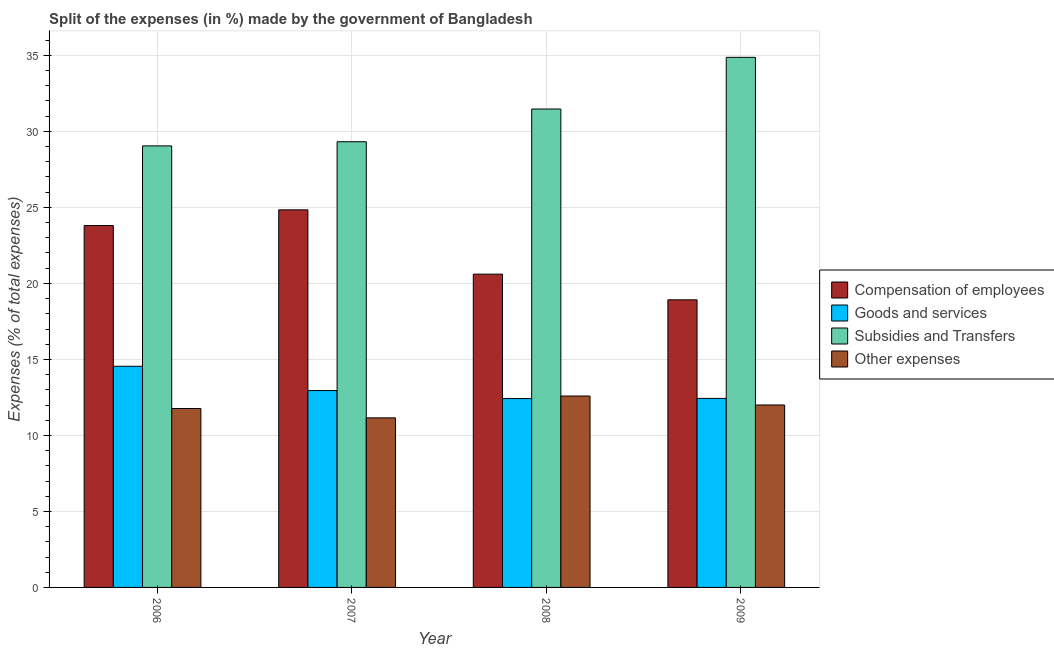How many different coloured bars are there?
Your answer should be compact. 4. How many groups of bars are there?
Give a very brief answer. 4. Are the number of bars on each tick of the X-axis equal?
Provide a succinct answer. Yes. How many bars are there on the 2nd tick from the right?
Offer a very short reply. 4. In how many cases, is the number of bars for a given year not equal to the number of legend labels?
Offer a very short reply. 0. What is the percentage of amount spent on other expenses in 2008?
Your answer should be compact. 12.59. Across all years, what is the maximum percentage of amount spent on compensation of employees?
Keep it short and to the point. 24.84. Across all years, what is the minimum percentage of amount spent on compensation of employees?
Your answer should be compact. 18.92. In which year was the percentage of amount spent on goods and services maximum?
Ensure brevity in your answer.  2006. What is the total percentage of amount spent on subsidies in the graph?
Offer a very short reply. 124.71. What is the difference between the percentage of amount spent on goods and services in 2007 and that in 2009?
Give a very brief answer. 0.52. What is the difference between the percentage of amount spent on subsidies in 2008 and the percentage of amount spent on goods and services in 2006?
Ensure brevity in your answer.  2.43. What is the average percentage of amount spent on compensation of employees per year?
Give a very brief answer. 22.04. In the year 2007, what is the difference between the percentage of amount spent on compensation of employees and percentage of amount spent on other expenses?
Ensure brevity in your answer.  0. In how many years, is the percentage of amount spent on other expenses greater than 31 %?
Give a very brief answer. 0. What is the ratio of the percentage of amount spent on compensation of employees in 2006 to that in 2007?
Give a very brief answer. 0.96. What is the difference between the highest and the second highest percentage of amount spent on subsidies?
Make the answer very short. 3.4. What is the difference between the highest and the lowest percentage of amount spent on compensation of employees?
Provide a succinct answer. 5.92. In how many years, is the percentage of amount spent on goods and services greater than the average percentage of amount spent on goods and services taken over all years?
Offer a very short reply. 1. Is the sum of the percentage of amount spent on goods and services in 2006 and 2007 greater than the maximum percentage of amount spent on compensation of employees across all years?
Provide a succinct answer. Yes. What does the 3rd bar from the left in 2006 represents?
Provide a short and direct response. Subsidies and Transfers. What does the 1st bar from the right in 2007 represents?
Offer a terse response. Other expenses. Is it the case that in every year, the sum of the percentage of amount spent on compensation of employees and percentage of amount spent on goods and services is greater than the percentage of amount spent on subsidies?
Offer a very short reply. No. Are all the bars in the graph horizontal?
Offer a very short reply. No. How many years are there in the graph?
Offer a very short reply. 4. How are the legend labels stacked?
Your response must be concise. Vertical. What is the title of the graph?
Your answer should be very brief. Split of the expenses (in %) made by the government of Bangladesh. What is the label or title of the X-axis?
Your answer should be compact. Year. What is the label or title of the Y-axis?
Offer a terse response. Expenses (% of total expenses). What is the Expenses (% of total expenses) of Compensation of employees in 2006?
Make the answer very short. 23.81. What is the Expenses (% of total expenses) of Goods and services in 2006?
Ensure brevity in your answer.  14.55. What is the Expenses (% of total expenses) in Subsidies and Transfers in 2006?
Make the answer very short. 29.05. What is the Expenses (% of total expenses) of Other expenses in 2006?
Offer a terse response. 11.77. What is the Expenses (% of total expenses) of Compensation of employees in 2007?
Your response must be concise. 24.84. What is the Expenses (% of total expenses) in Goods and services in 2007?
Make the answer very short. 12.95. What is the Expenses (% of total expenses) in Subsidies and Transfers in 2007?
Offer a very short reply. 29.32. What is the Expenses (% of total expenses) in Other expenses in 2007?
Your answer should be very brief. 11.16. What is the Expenses (% of total expenses) of Compensation of employees in 2008?
Make the answer very short. 20.61. What is the Expenses (% of total expenses) in Goods and services in 2008?
Provide a succinct answer. 12.42. What is the Expenses (% of total expenses) of Subsidies and Transfers in 2008?
Offer a very short reply. 31.47. What is the Expenses (% of total expenses) of Other expenses in 2008?
Give a very brief answer. 12.59. What is the Expenses (% of total expenses) in Compensation of employees in 2009?
Your answer should be very brief. 18.92. What is the Expenses (% of total expenses) of Goods and services in 2009?
Offer a very short reply. 12.44. What is the Expenses (% of total expenses) of Subsidies and Transfers in 2009?
Provide a short and direct response. 34.87. What is the Expenses (% of total expenses) in Other expenses in 2009?
Offer a very short reply. 12. Across all years, what is the maximum Expenses (% of total expenses) of Compensation of employees?
Your response must be concise. 24.84. Across all years, what is the maximum Expenses (% of total expenses) in Goods and services?
Keep it short and to the point. 14.55. Across all years, what is the maximum Expenses (% of total expenses) of Subsidies and Transfers?
Ensure brevity in your answer.  34.87. Across all years, what is the maximum Expenses (% of total expenses) of Other expenses?
Provide a short and direct response. 12.59. Across all years, what is the minimum Expenses (% of total expenses) of Compensation of employees?
Ensure brevity in your answer.  18.92. Across all years, what is the minimum Expenses (% of total expenses) of Goods and services?
Offer a terse response. 12.42. Across all years, what is the minimum Expenses (% of total expenses) of Subsidies and Transfers?
Your answer should be compact. 29.05. Across all years, what is the minimum Expenses (% of total expenses) of Other expenses?
Offer a terse response. 11.16. What is the total Expenses (% of total expenses) in Compensation of employees in the graph?
Provide a succinct answer. 88.17. What is the total Expenses (% of total expenses) of Goods and services in the graph?
Your answer should be very brief. 52.36. What is the total Expenses (% of total expenses) of Subsidies and Transfers in the graph?
Keep it short and to the point. 124.71. What is the total Expenses (% of total expenses) of Other expenses in the graph?
Ensure brevity in your answer.  47.52. What is the difference between the Expenses (% of total expenses) of Compensation of employees in 2006 and that in 2007?
Ensure brevity in your answer.  -1.03. What is the difference between the Expenses (% of total expenses) of Goods and services in 2006 and that in 2007?
Keep it short and to the point. 1.6. What is the difference between the Expenses (% of total expenses) of Subsidies and Transfers in 2006 and that in 2007?
Provide a succinct answer. -0.27. What is the difference between the Expenses (% of total expenses) of Other expenses in 2006 and that in 2007?
Offer a very short reply. 0.62. What is the difference between the Expenses (% of total expenses) of Compensation of employees in 2006 and that in 2008?
Ensure brevity in your answer.  3.2. What is the difference between the Expenses (% of total expenses) of Goods and services in 2006 and that in 2008?
Ensure brevity in your answer.  2.12. What is the difference between the Expenses (% of total expenses) of Subsidies and Transfers in 2006 and that in 2008?
Offer a very short reply. -2.43. What is the difference between the Expenses (% of total expenses) of Other expenses in 2006 and that in 2008?
Keep it short and to the point. -0.82. What is the difference between the Expenses (% of total expenses) in Compensation of employees in 2006 and that in 2009?
Your answer should be compact. 4.89. What is the difference between the Expenses (% of total expenses) of Goods and services in 2006 and that in 2009?
Provide a succinct answer. 2.11. What is the difference between the Expenses (% of total expenses) in Subsidies and Transfers in 2006 and that in 2009?
Your response must be concise. -5.83. What is the difference between the Expenses (% of total expenses) in Other expenses in 2006 and that in 2009?
Provide a succinct answer. -0.23. What is the difference between the Expenses (% of total expenses) of Compensation of employees in 2007 and that in 2008?
Ensure brevity in your answer.  4.23. What is the difference between the Expenses (% of total expenses) in Goods and services in 2007 and that in 2008?
Keep it short and to the point. 0.53. What is the difference between the Expenses (% of total expenses) in Subsidies and Transfers in 2007 and that in 2008?
Provide a succinct answer. -2.15. What is the difference between the Expenses (% of total expenses) of Other expenses in 2007 and that in 2008?
Make the answer very short. -1.44. What is the difference between the Expenses (% of total expenses) in Compensation of employees in 2007 and that in 2009?
Ensure brevity in your answer.  5.92. What is the difference between the Expenses (% of total expenses) in Goods and services in 2007 and that in 2009?
Offer a very short reply. 0.52. What is the difference between the Expenses (% of total expenses) in Subsidies and Transfers in 2007 and that in 2009?
Provide a succinct answer. -5.55. What is the difference between the Expenses (% of total expenses) in Other expenses in 2007 and that in 2009?
Keep it short and to the point. -0.85. What is the difference between the Expenses (% of total expenses) in Compensation of employees in 2008 and that in 2009?
Make the answer very short. 1.69. What is the difference between the Expenses (% of total expenses) in Goods and services in 2008 and that in 2009?
Your answer should be compact. -0.01. What is the difference between the Expenses (% of total expenses) in Subsidies and Transfers in 2008 and that in 2009?
Your answer should be compact. -3.4. What is the difference between the Expenses (% of total expenses) in Other expenses in 2008 and that in 2009?
Provide a short and direct response. 0.59. What is the difference between the Expenses (% of total expenses) in Compensation of employees in 2006 and the Expenses (% of total expenses) in Goods and services in 2007?
Ensure brevity in your answer.  10.85. What is the difference between the Expenses (% of total expenses) of Compensation of employees in 2006 and the Expenses (% of total expenses) of Subsidies and Transfers in 2007?
Keep it short and to the point. -5.51. What is the difference between the Expenses (% of total expenses) in Compensation of employees in 2006 and the Expenses (% of total expenses) in Other expenses in 2007?
Keep it short and to the point. 12.65. What is the difference between the Expenses (% of total expenses) of Goods and services in 2006 and the Expenses (% of total expenses) of Subsidies and Transfers in 2007?
Ensure brevity in your answer.  -14.77. What is the difference between the Expenses (% of total expenses) in Goods and services in 2006 and the Expenses (% of total expenses) in Other expenses in 2007?
Ensure brevity in your answer.  3.39. What is the difference between the Expenses (% of total expenses) in Subsidies and Transfers in 2006 and the Expenses (% of total expenses) in Other expenses in 2007?
Your response must be concise. 17.89. What is the difference between the Expenses (% of total expenses) in Compensation of employees in 2006 and the Expenses (% of total expenses) in Goods and services in 2008?
Your response must be concise. 11.38. What is the difference between the Expenses (% of total expenses) in Compensation of employees in 2006 and the Expenses (% of total expenses) in Subsidies and Transfers in 2008?
Keep it short and to the point. -7.67. What is the difference between the Expenses (% of total expenses) of Compensation of employees in 2006 and the Expenses (% of total expenses) of Other expenses in 2008?
Give a very brief answer. 11.21. What is the difference between the Expenses (% of total expenses) in Goods and services in 2006 and the Expenses (% of total expenses) in Subsidies and Transfers in 2008?
Offer a very short reply. -16.92. What is the difference between the Expenses (% of total expenses) of Goods and services in 2006 and the Expenses (% of total expenses) of Other expenses in 2008?
Your answer should be very brief. 1.96. What is the difference between the Expenses (% of total expenses) of Subsidies and Transfers in 2006 and the Expenses (% of total expenses) of Other expenses in 2008?
Keep it short and to the point. 16.46. What is the difference between the Expenses (% of total expenses) in Compensation of employees in 2006 and the Expenses (% of total expenses) in Goods and services in 2009?
Offer a very short reply. 11.37. What is the difference between the Expenses (% of total expenses) in Compensation of employees in 2006 and the Expenses (% of total expenses) in Subsidies and Transfers in 2009?
Keep it short and to the point. -11.07. What is the difference between the Expenses (% of total expenses) of Compensation of employees in 2006 and the Expenses (% of total expenses) of Other expenses in 2009?
Give a very brief answer. 11.8. What is the difference between the Expenses (% of total expenses) of Goods and services in 2006 and the Expenses (% of total expenses) of Subsidies and Transfers in 2009?
Ensure brevity in your answer.  -20.32. What is the difference between the Expenses (% of total expenses) in Goods and services in 2006 and the Expenses (% of total expenses) in Other expenses in 2009?
Give a very brief answer. 2.55. What is the difference between the Expenses (% of total expenses) in Subsidies and Transfers in 2006 and the Expenses (% of total expenses) in Other expenses in 2009?
Your answer should be compact. 17.04. What is the difference between the Expenses (% of total expenses) of Compensation of employees in 2007 and the Expenses (% of total expenses) of Goods and services in 2008?
Offer a terse response. 12.41. What is the difference between the Expenses (% of total expenses) in Compensation of employees in 2007 and the Expenses (% of total expenses) in Subsidies and Transfers in 2008?
Provide a succinct answer. -6.63. What is the difference between the Expenses (% of total expenses) in Compensation of employees in 2007 and the Expenses (% of total expenses) in Other expenses in 2008?
Provide a succinct answer. 12.25. What is the difference between the Expenses (% of total expenses) in Goods and services in 2007 and the Expenses (% of total expenses) in Subsidies and Transfers in 2008?
Make the answer very short. -18.52. What is the difference between the Expenses (% of total expenses) of Goods and services in 2007 and the Expenses (% of total expenses) of Other expenses in 2008?
Your answer should be compact. 0.36. What is the difference between the Expenses (% of total expenses) in Subsidies and Transfers in 2007 and the Expenses (% of total expenses) in Other expenses in 2008?
Your response must be concise. 16.73. What is the difference between the Expenses (% of total expenses) in Compensation of employees in 2007 and the Expenses (% of total expenses) in Goods and services in 2009?
Your answer should be very brief. 12.4. What is the difference between the Expenses (% of total expenses) of Compensation of employees in 2007 and the Expenses (% of total expenses) of Subsidies and Transfers in 2009?
Offer a very short reply. -10.03. What is the difference between the Expenses (% of total expenses) of Compensation of employees in 2007 and the Expenses (% of total expenses) of Other expenses in 2009?
Offer a very short reply. 12.84. What is the difference between the Expenses (% of total expenses) in Goods and services in 2007 and the Expenses (% of total expenses) in Subsidies and Transfers in 2009?
Your answer should be compact. -21.92. What is the difference between the Expenses (% of total expenses) in Goods and services in 2007 and the Expenses (% of total expenses) in Other expenses in 2009?
Your response must be concise. 0.95. What is the difference between the Expenses (% of total expenses) of Subsidies and Transfers in 2007 and the Expenses (% of total expenses) of Other expenses in 2009?
Keep it short and to the point. 17.32. What is the difference between the Expenses (% of total expenses) of Compensation of employees in 2008 and the Expenses (% of total expenses) of Goods and services in 2009?
Ensure brevity in your answer.  8.17. What is the difference between the Expenses (% of total expenses) in Compensation of employees in 2008 and the Expenses (% of total expenses) in Subsidies and Transfers in 2009?
Give a very brief answer. -14.26. What is the difference between the Expenses (% of total expenses) in Compensation of employees in 2008 and the Expenses (% of total expenses) in Other expenses in 2009?
Provide a short and direct response. 8.61. What is the difference between the Expenses (% of total expenses) in Goods and services in 2008 and the Expenses (% of total expenses) in Subsidies and Transfers in 2009?
Make the answer very short. -22.45. What is the difference between the Expenses (% of total expenses) in Goods and services in 2008 and the Expenses (% of total expenses) in Other expenses in 2009?
Keep it short and to the point. 0.42. What is the difference between the Expenses (% of total expenses) in Subsidies and Transfers in 2008 and the Expenses (% of total expenses) in Other expenses in 2009?
Your answer should be very brief. 19.47. What is the average Expenses (% of total expenses) in Compensation of employees per year?
Your response must be concise. 22.04. What is the average Expenses (% of total expenses) in Goods and services per year?
Offer a terse response. 13.09. What is the average Expenses (% of total expenses) of Subsidies and Transfers per year?
Your response must be concise. 31.18. What is the average Expenses (% of total expenses) of Other expenses per year?
Offer a terse response. 11.88. In the year 2006, what is the difference between the Expenses (% of total expenses) in Compensation of employees and Expenses (% of total expenses) in Goods and services?
Provide a succinct answer. 9.26. In the year 2006, what is the difference between the Expenses (% of total expenses) of Compensation of employees and Expenses (% of total expenses) of Subsidies and Transfers?
Your response must be concise. -5.24. In the year 2006, what is the difference between the Expenses (% of total expenses) in Compensation of employees and Expenses (% of total expenses) in Other expenses?
Your answer should be compact. 12.03. In the year 2006, what is the difference between the Expenses (% of total expenses) in Goods and services and Expenses (% of total expenses) in Subsidies and Transfers?
Ensure brevity in your answer.  -14.5. In the year 2006, what is the difference between the Expenses (% of total expenses) of Goods and services and Expenses (% of total expenses) of Other expenses?
Provide a short and direct response. 2.78. In the year 2006, what is the difference between the Expenses (% of total expenses) of Subsidies and Transfers and Expenses (% of total expenses) of Other expenses?
Your response must be concise. 17.27. In the year 2007, what is the difference between the Expenses (% of total expenses) of Compensation of employees and Expenses (% of total expenses) of Goods and services?
Keep it short and to the point. 11.89. In the year 2007, what is the difference between the Expenses (% of total expenses) in Compensation of employees and Expenses (% of total expenses) in Subsidies and Transfers?
Make the answer very short. -4.48. In the year 2007, what is the difference between the Expenses (% of total expenses) in Compensation of employees and Expenses (% of total expenses) in Other expenses?
Ensure brevity in your answer.  13.68. In the year 2007, what is the difference between the Expenses (% of total expenses) of Goods and services and Expenses (% of total expenses) of Subsidies and Transfers?
Offer a very short reply. -16.37. In the year 2007, what is the difference between the Expenses (% of total expenses) of Goods and services and Expenses (% of total expenses) of Other expenses?
Provide a short and direct response. 1.8. In the year 2007, what is the difference between the Expenses (% of total expenses) in Subsidies and Transfers and Expenses (% of total expenses) in Other expenses?
Your response must be concise. 18.16. In the year 2008, what is the difference between the Expenses (% of total expenses) in Compensation of employees and Expenses (% of total expenses) in Goods and services?
Keep it short and to the point. 8.18. In the year 2008, what is the difference between the Expenses (% of total expenses) in Compensation of employees and Expenses (% of total expenses) in Subsidies and Transfers?
Ensure brevity in your answer.  -10.86. In the year 2008, what is the difference between the Expenses (% of total expenses) in Compensation of employees and Expenses (% of total expenses) in Other expenses?
Give a very brief answer. 8.02. In the year 2008, what is the difference between the Expenses (% of total expenses) in Goods and services and Expenses (% of total expenses) in Subsidies and Transfers?
Make the answer very short. -19.05. In the year 2008, what is the difference between the Expenses (% of total expenses) in Goods and services and Expenses (% of total expenses) in Other expenses?
Your answer should be very brief. -0.17. In the year 2008, what is the difference between the Expenses (% of total expenses) in Subsidies and Transfers and Expenses (% of total expenses) in Other expenses?
Keep it short and to the point. 18.88. In the year 2009, what is the difference between the Expenses (% of total expenses) in Compensation of employees and Expenses (% of total expenses) in Goods and services?
Provide a short and direct response. 6.48. In the year 2009, what is the difference between the Expenses (% of total expenses) in Compensation of employees and Expenses (% of total expenses) in Subsidies and Transfers?
Offer a very short reply. -15.95. In the year 2009, what is the difference between the Expenses (% of total expenses) in Compensation of employees and Expenses (% of total expenses) in Other expenses?
Offer a very short reply. 6.92. In the year 2009, what is the difference between the Expenses (% of total expenses) in Goods and services and Expenses (% of total expenses) in Subsidies and Transfers?
Make the answer very short. -22.44. In the year 2009, what is the difference between the Expenses (% of total expenses) of Goods and services and Expenses (% of total expenses) of Other expenses?
Provide a short and direct response. 0.43. In the year 2009, what is the difference between the Expenses (% of total expenses) in Subsidies and Transfers and Expenses (% of total expenses) in Other expenses?
Provide a succinct answer. 22.87. What is the ratio of the Expenses (% of total expenses) of Compensation of employees in 2006 to that in 2007?
Give a very brief answer. 0.96. What is the ratio of the Expenses (% of total expenses) in Goods and services in 2006 to that in 2007?
Provide a succinct answer. 1.12. What is the ratio of the Expenses (% of total expenses) of Subsidies and Transfers in 2006 to that in 2007?
Offer a very short reply. 0.99. What is the ratio of the Expenses (% of total expenses) in Other expenses in 2006 to that in 2007?
Your answer should be very brief. 1.06. What is the ratio of the Expenses (% of total expenses) of Compensation of employees in 2006 to that in 2008?
Provide a succinct answer. 1.16. What is the ratio of the Expenses (% of total expenses) in Goods and services in 2006 to that in 2008?
Your answer should be compact. 1.17. What is the ratio of the Expenses (% of total expenses) in Subsidies and Transfers in 2006 to that in 2008?
Your answer should be very brief. 0.92. What is the ratio of the Expenses (% of total expenses) of Other expenses in 2006 to that in 2008?
Provide a short and direct response. 0.93. What is the ratio of the Expenses (% of total expenses) of Compensation of employees in 2006 to that in 2009?
Your answer should be very brief. 1.26. What is the ratio of the Expenses (% of total expenses) in Goods and services in 2006 to that in 2009?
Your response must be concise. 1.17. What is the ratio of the Expenses (% of total expenses) of Subsidies and Transfers in 2006 to that in 2009?
Your answer should be compact. 0.83. What is the ratio of the Expenses (% of total expenses) in Other expenses in 2006 to that in 2009?
Give a very brief answer. 0.98. What is the ratio of the Expenses (% of total expenses) in Compensation of employees in 2007 to that in 2008?
Your answer should be very brief. 1.21. What is the ratio of the Expenses (% of total expenses) in Goods and services in 2007 to that in 2008?
Offer a very short reply. 1.04. What is the ratio of the Expenses (% of total expenses) in Subsidies and Transfers in 2007 to that in 2008?
Provide a succinct answer. 0.93. What is the ratio of the Expenses (% of total expenses) of Other expenses in 2007 to that in 2008?
Provide a short and direct response. 0.89. What is the ratio of the Expenses (% of total expenses) of Compensation of employees in 2007 to that in 2009?
Provide a succinct answer. 1.31. What is the ratio of the Expenses (% of total expenses) in Goods and services in 2007 to that in 2009?
Your answer should be very brief. 1.04. What is the ratio of the Expenses (% of total expenses) of Subsidies and Transfers in 2007 to that in 2009?
Give a very brief answer. 0.84. What is the ratio of the Expenses (% of total expenses) in Other expenses in 2007 to that in 2009?
Your answer should be very brief. 0.93. What is the ratio of the Expenses (% of total expenses) in Compensation of employees in 2008 to that in 2009?
Offer a very short reply. 1.09. What is the ratio of the Expenses (% of total expenses) in Goods and services in 2008 to that in 2009?
Provide a succinct answer. 1. What is the ratio of the Expenses (% of total expenses) in Subsidies and Transfers in 2008 to that in 2009?
Provide a short and direct response. 0.9. What is the ratio of the Expenses (% of total expenses) of Other expenses in 2008 to that in 2009?
Your response must be concise. 1.05. What is the difference between the highest and the second highest Expenses (% of total expenses) in Compensation of employees?
Provide a succinct answer. 1.03. What is the difference between the highest and the second highest Expenses (% of total expenses) of Goods and services?
Your answer should be compact. 1.6. What is the difference between the highest and the second highest Expenses (% of total expenses) in Subsidies and Transfers?
Your response must be concise. 3.4. What is the difference between the highest and the second highest Expenses (% of total expenses) of Other expenses?
Make the answer very short. 0.59. What is the difference between the highest and the lowest Expenses (% of total expenses) of Compensation of employees?
Your response must be concise. 5.92. What is the difference between the highest and the lowest Expenses (% of total expenses) of Goods and services?
Your answer should be compact. 2.12. What is the difference between the highest and the lowest Expenses (% of total expenses) in Subsidies and Transfers?
Ensure brevity in your answer.  5.83. What is the difference between the highest and the lowest Expenses (% of total expenses) in Other expenses?
Provide a succinct answer. 1.44. 